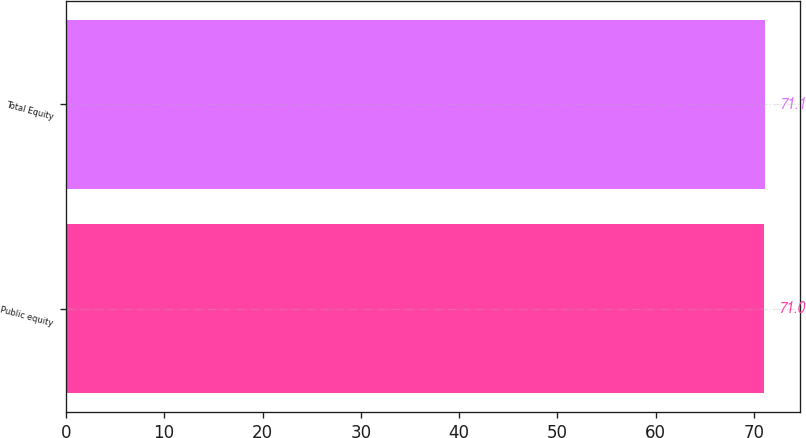Convert chart to OTSL. <chart><loc_0><loc_0><loc_500><loc_500><bar_chart><fcel>Public equity<fcel>Total Equity<nl><fcel>71<fcel>71.1<nl></chart> 